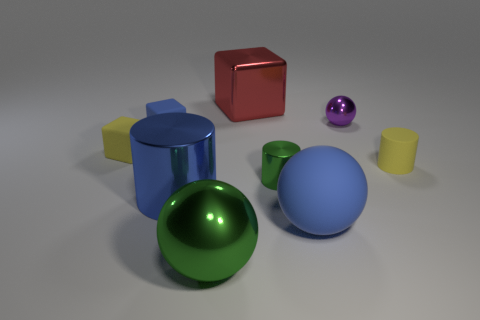Can you describe the lighting in the scene? Certainly. The lighting in the scene is soft and diffused, creating gentle shadows on the ground beneath each object. There's no harsh glare, indicating the light source is not very close, or it's being softened by something else, like a screen. This type of lighting brings out the colours and textures of the objects without causing heavy or stark contrasts.  How does the lighting affect the appearance of the objects? The lighting plays a crucial role in accentuating the objects' surfaces, often manifesting the material qualities of each object. Reflective surfaces, like those of the metallic spheres, have highlights that show their glossy nature. In contrast, the cubes with matte surfaces do not reflect the light directly but rather scatter it, giving an even distribution of color with less intense reflections. 